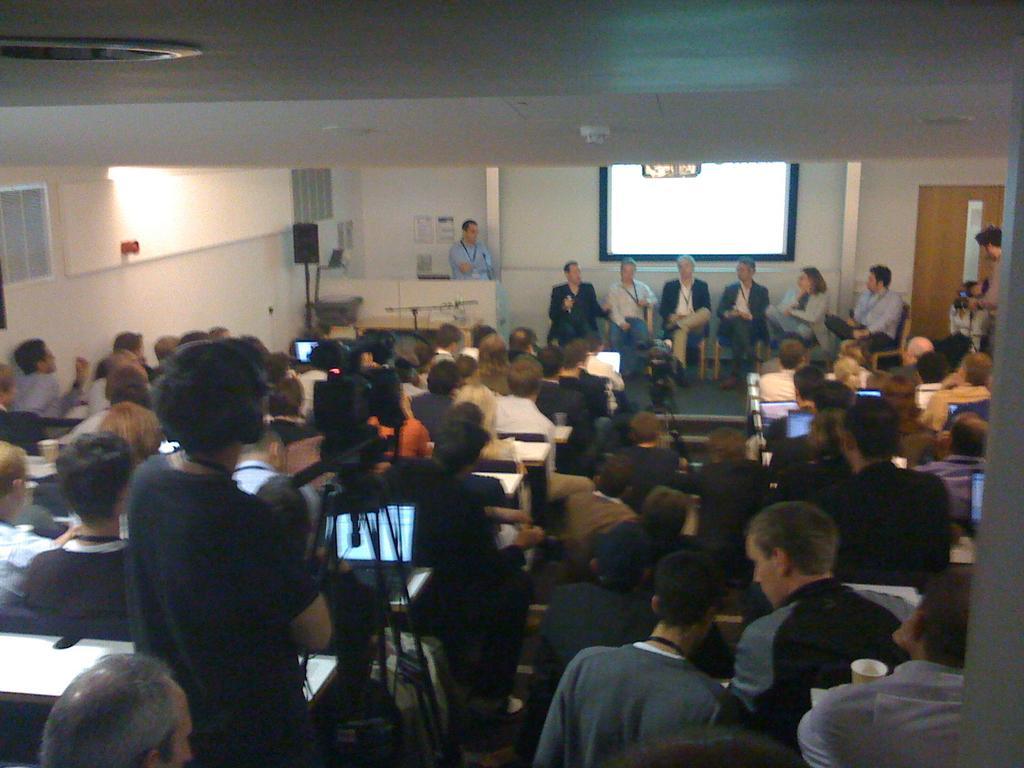Describe this image in one or two sentences. In this picture, we see many people are sitting on the benches. In front of them, we see the table. The man in front of the picture is standing and in front of him, we see the video camera. In the middle of the picture, we see the camera stand. We see six people are sitting on the chairs on the stage. Beside them, we see a man in blue shirt is standing. Behind him, we see a white wall on which the poster is posted. In the background, we see the white wall and the projector screen. At the top, we see the ceiling of the room. On the right side, we see a door and a man is standing beside the door. This picture is clicked in the conference hall. 